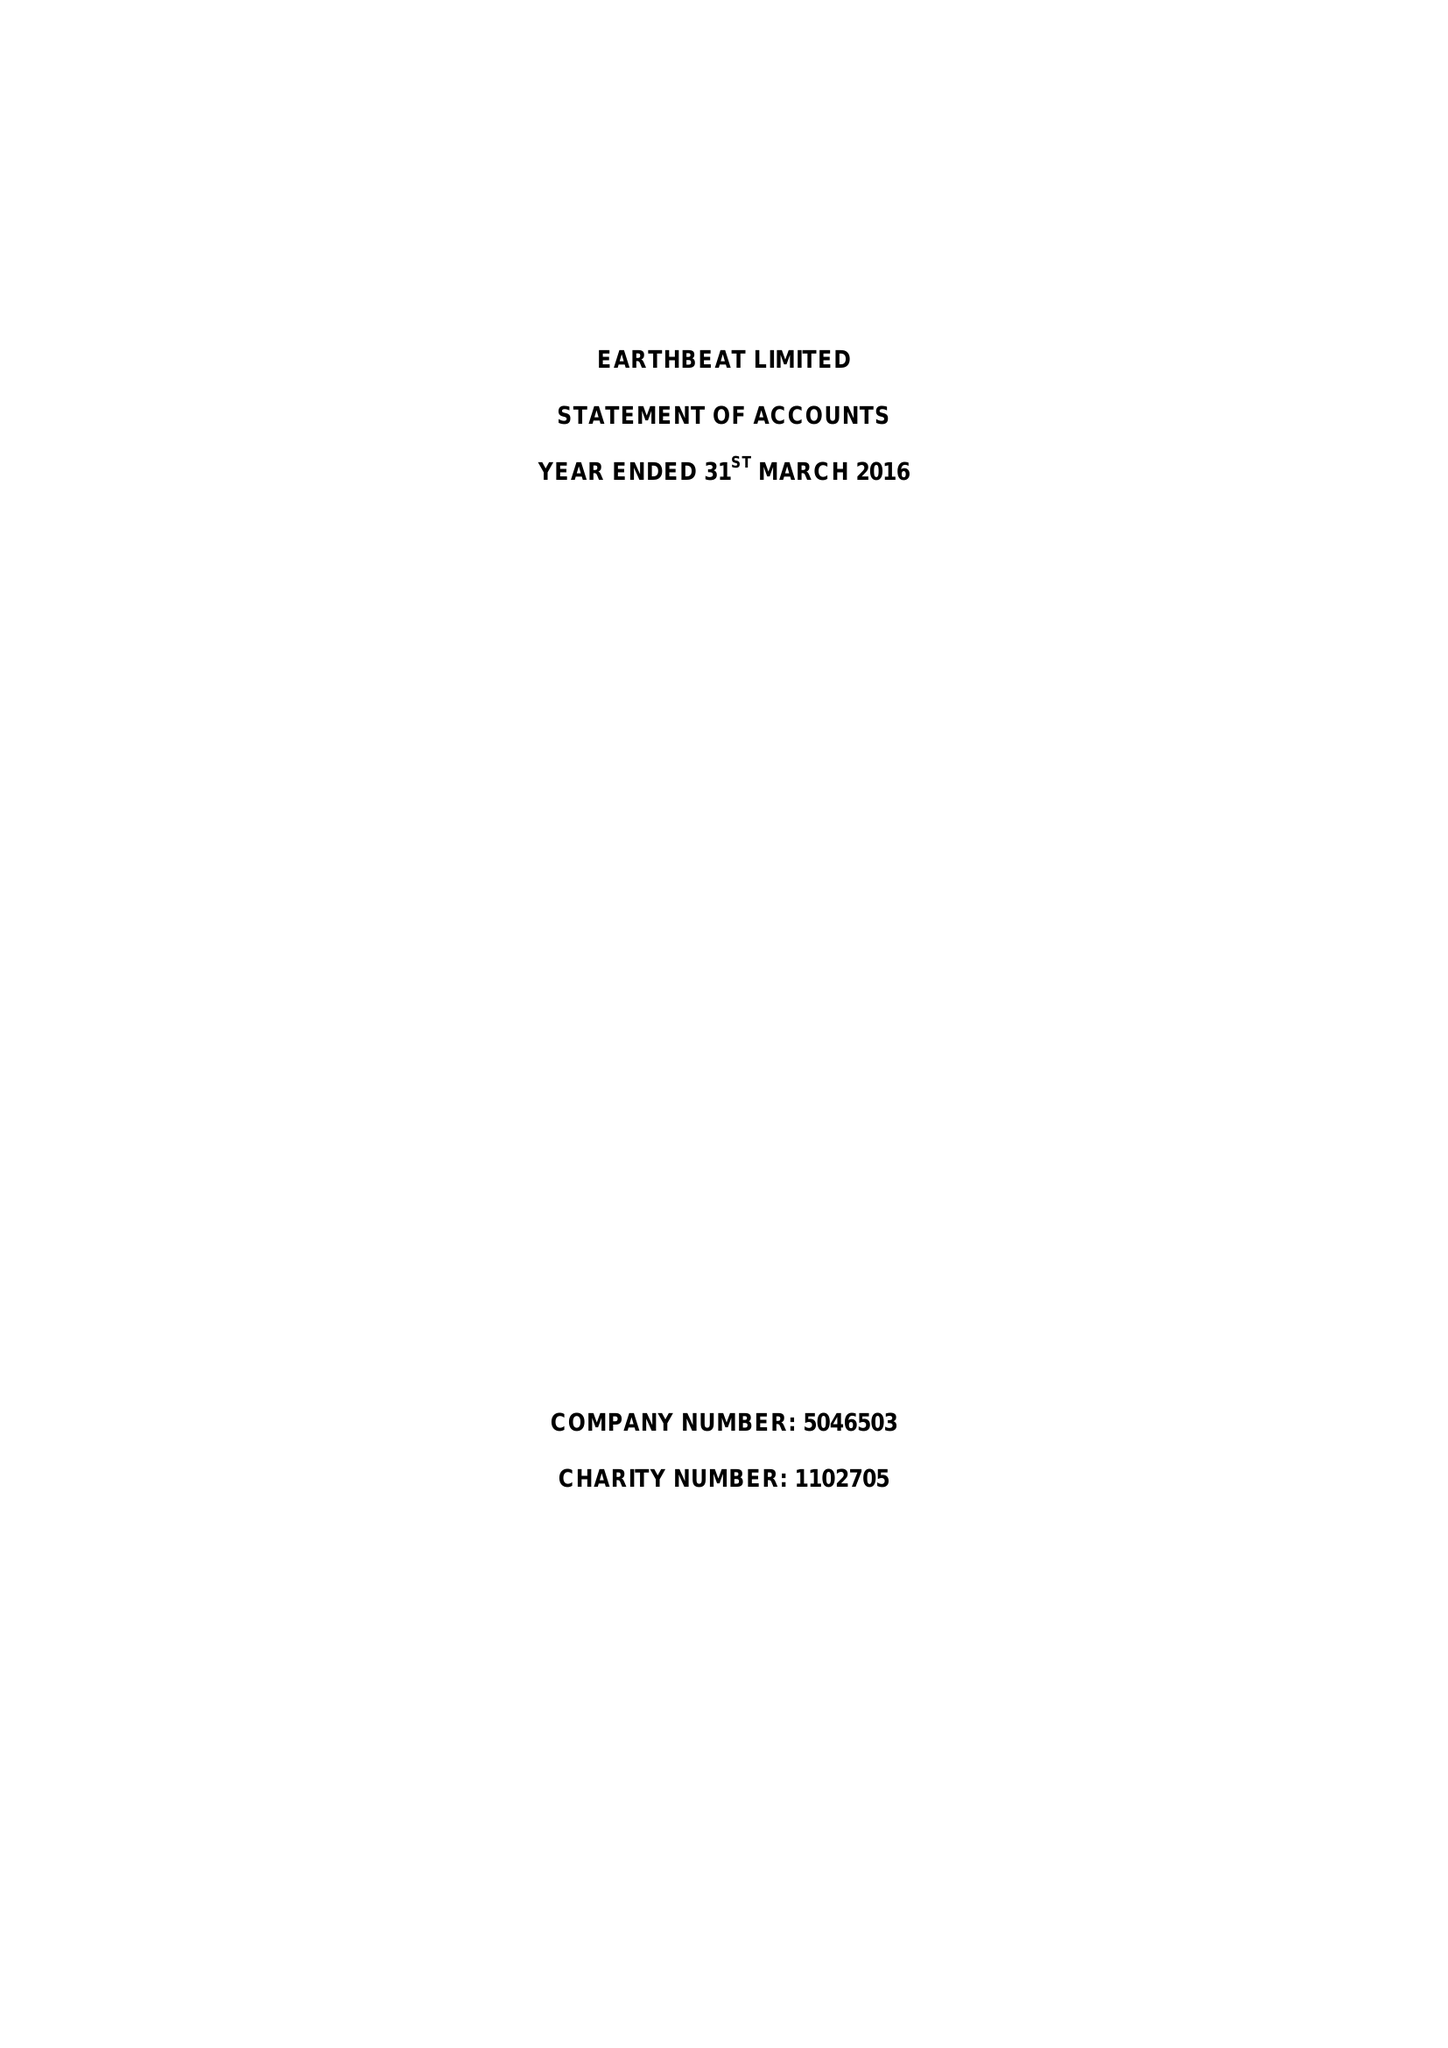What is the value for the spending_annually_in_british_pounds?
Answer the question using a single word or phrase. 298807.00 